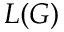<formula> <loc_0><loc_0><loc_500><loc_500>L ( G )</formula> 